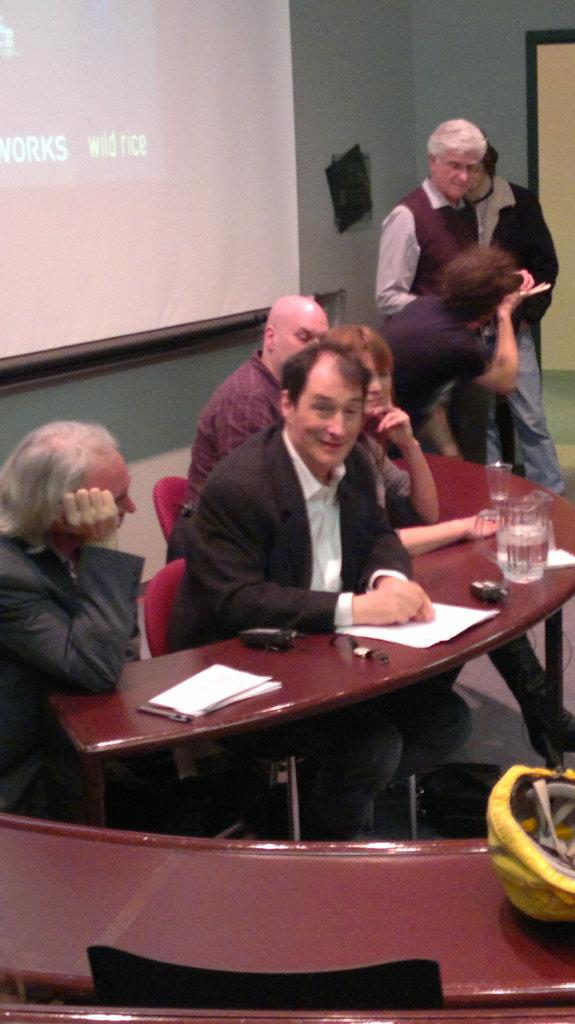How many people are sitting near the table in the image? There are four people sitting on chairs near the table in the image. What items can be seen on the table? Papers, a jar, and glasses are visible on the table in the image. What is the purpose of the projector screen in the image? The projector screen is likely used for presentations or displaying visuals during a meeting or event. Is there a swing visible in the image? No, there is no swing present in the image. Is there a rainstorm occurring in the image? No, there is no rainstorm depicted in the image. 